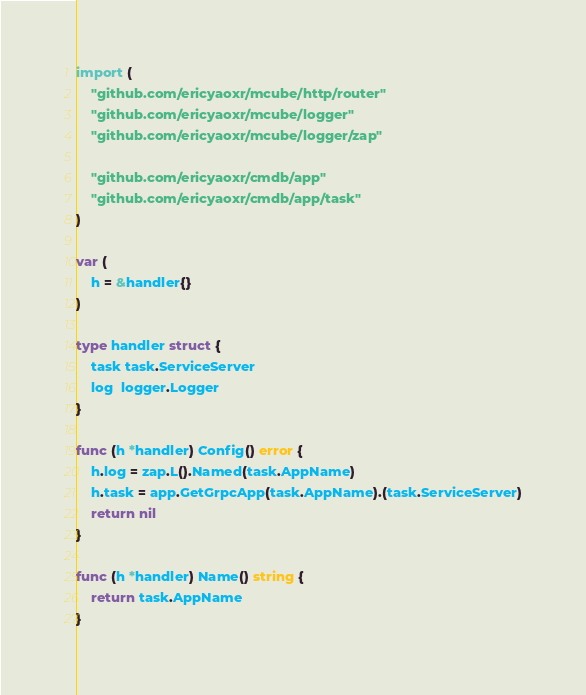<code> <loc_0><loc_0><loc_500><loc_500><_Go_>
import (
	"github.com/ericyaoxr/mcube/http/router"
	"github.com/ericyaoxr/mcube/logger"
	"github.com/ericyaoxr/mcube/logger/zap"

	"github.com/ericyaoxr/cmdb/app"
	"github.com/ericyaoxr/cmdb/app/task"
)

var (
	h = &handler{}
)

type handler struct {
	task task.ServiceServer
	log  logger.Logger
}

func (h *handler) Config() error {
	h.log = zap.L().Named(task.AppName)
	h.task = app.GetGrpcApp(task.AppName).(task.ServiceServer)
	return nil
}

func (h *handler) Name() string {
	return task.AppName
}
</code> 